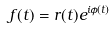<formula> <loc_0><loc_0><loc_500><loc_500>f ( t ) = r ( t ) e ^ { i \phi ( t ) }</formula> 